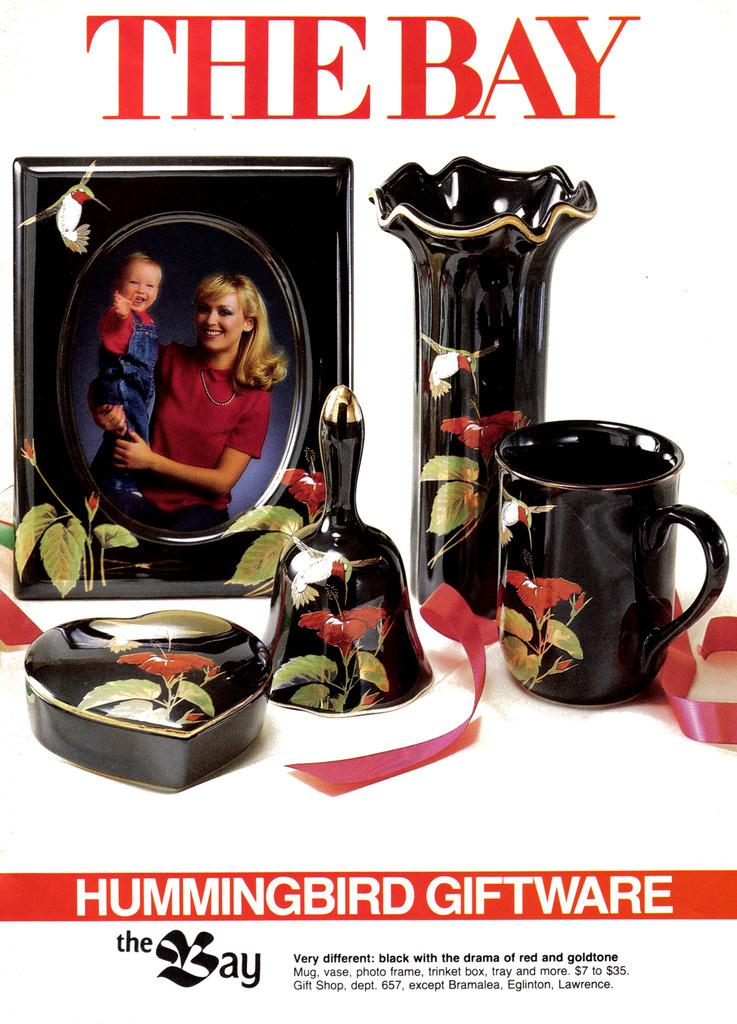<image>
Give a short and clear explanation of the subsequent image. An advertisement for Hummingbird Giftware shows various black porcelain items. 